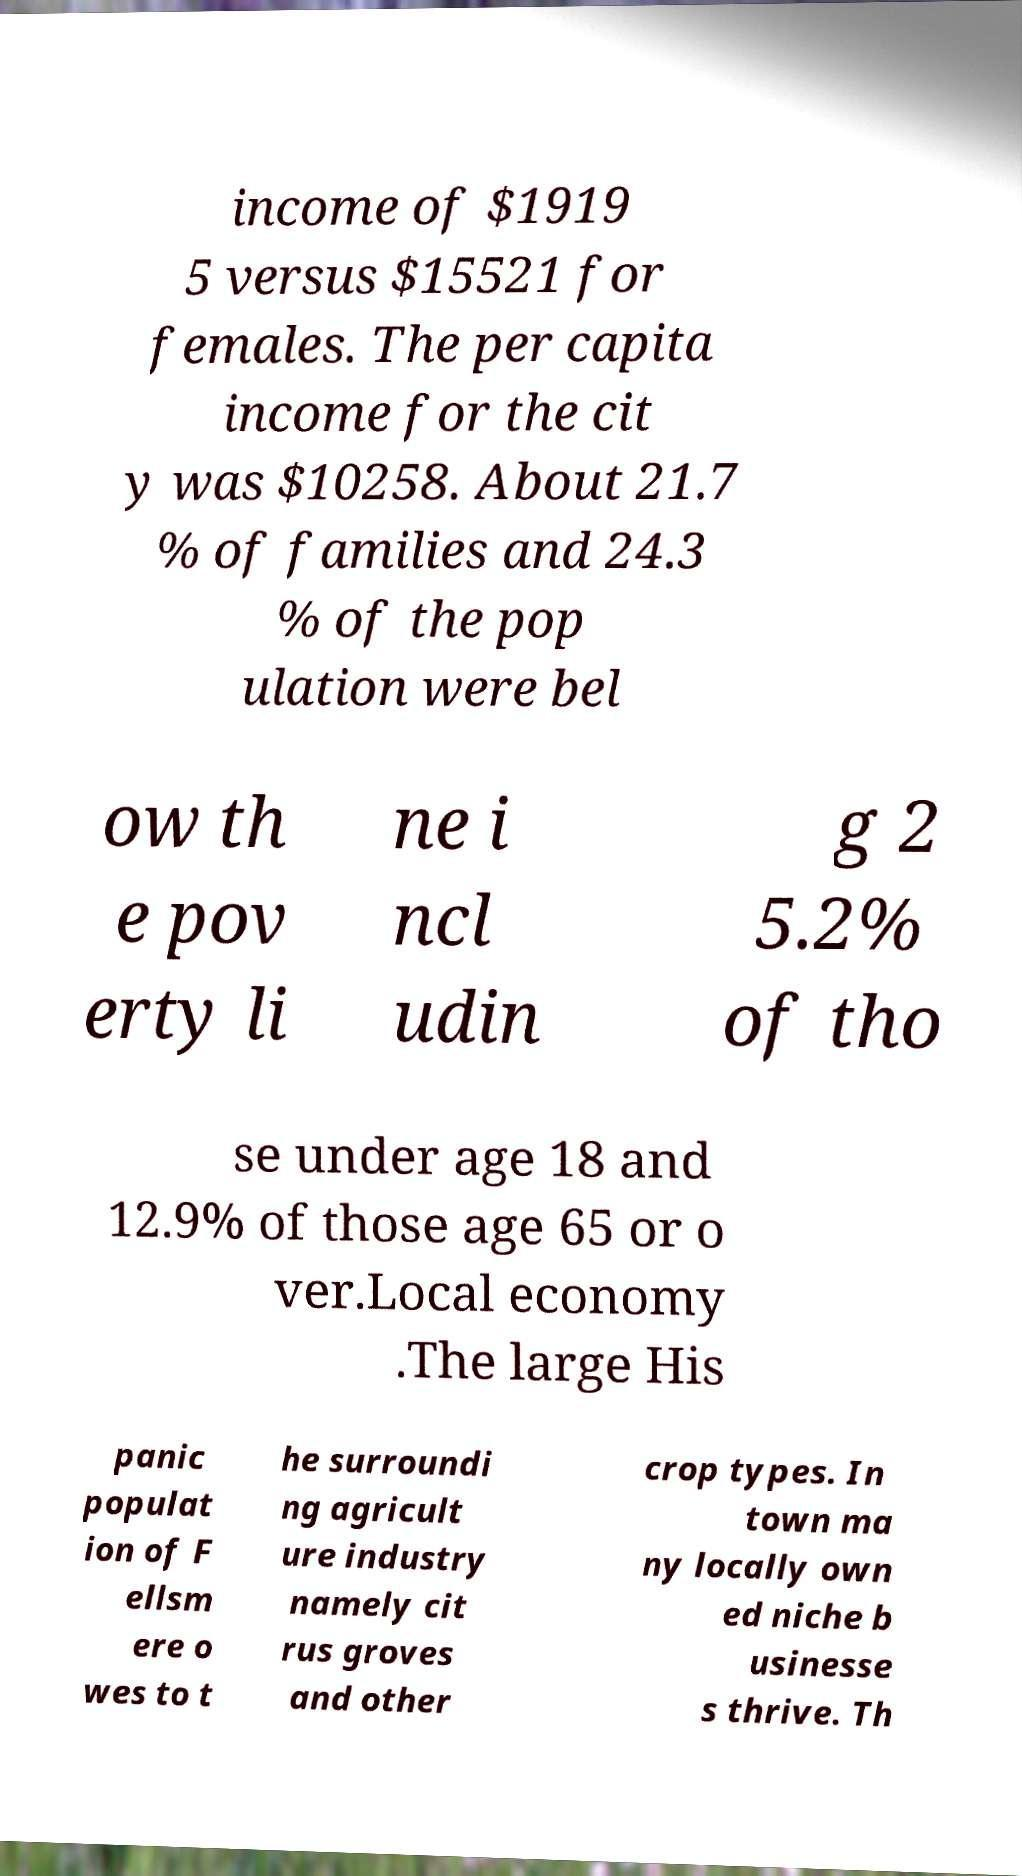Please read and relay the text visible in this image. What does it say? income of $1919 5 versus $15521 for females. The per capita income for the cit y was $10258. About 21.7 % of families and 24.3 % of the pop ulation were bel ow th e pov erty li ne i ncl udin g 2 5.2% of tho se under age 18 and 12.9% of those age 65 or o ver.Local economy .The large His panic populat ion of F ellsm ere o wes to t he surroundi ng agricult ure industry namely cit rus groves and other crop types. In town ma ny locally own ed niche b usinesse s thrive. Th 